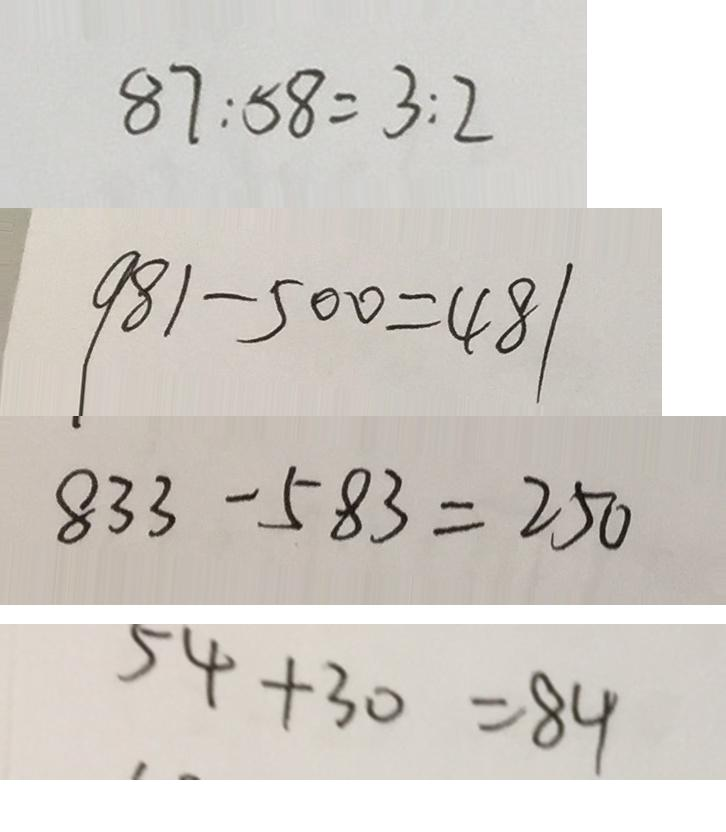<formula> <loc_0><loc_0><loc_500><loc_500>8 7 : 5 8 = 3 : 2 
 9 8 1 - 5 0 0 = 4 8 1 
 8 3 3 - 5 8 3 = 2 5 0 
 5 4 + 3 0 = 8 4</formula> 